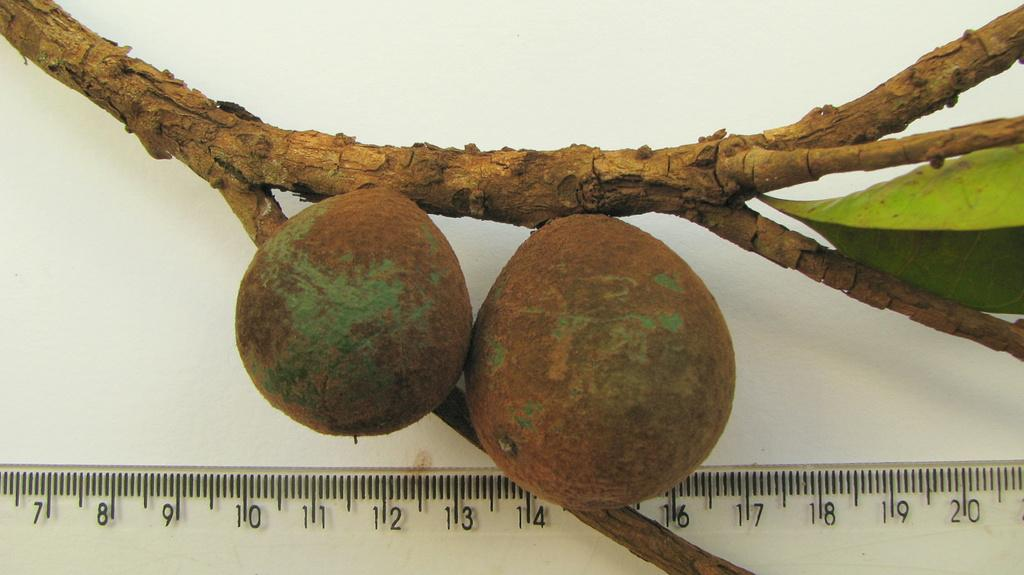<image>
Offer a succinct explanation of the picture presented. clear ruler only showing 7 thru 20 inches with a tree branch next to it 